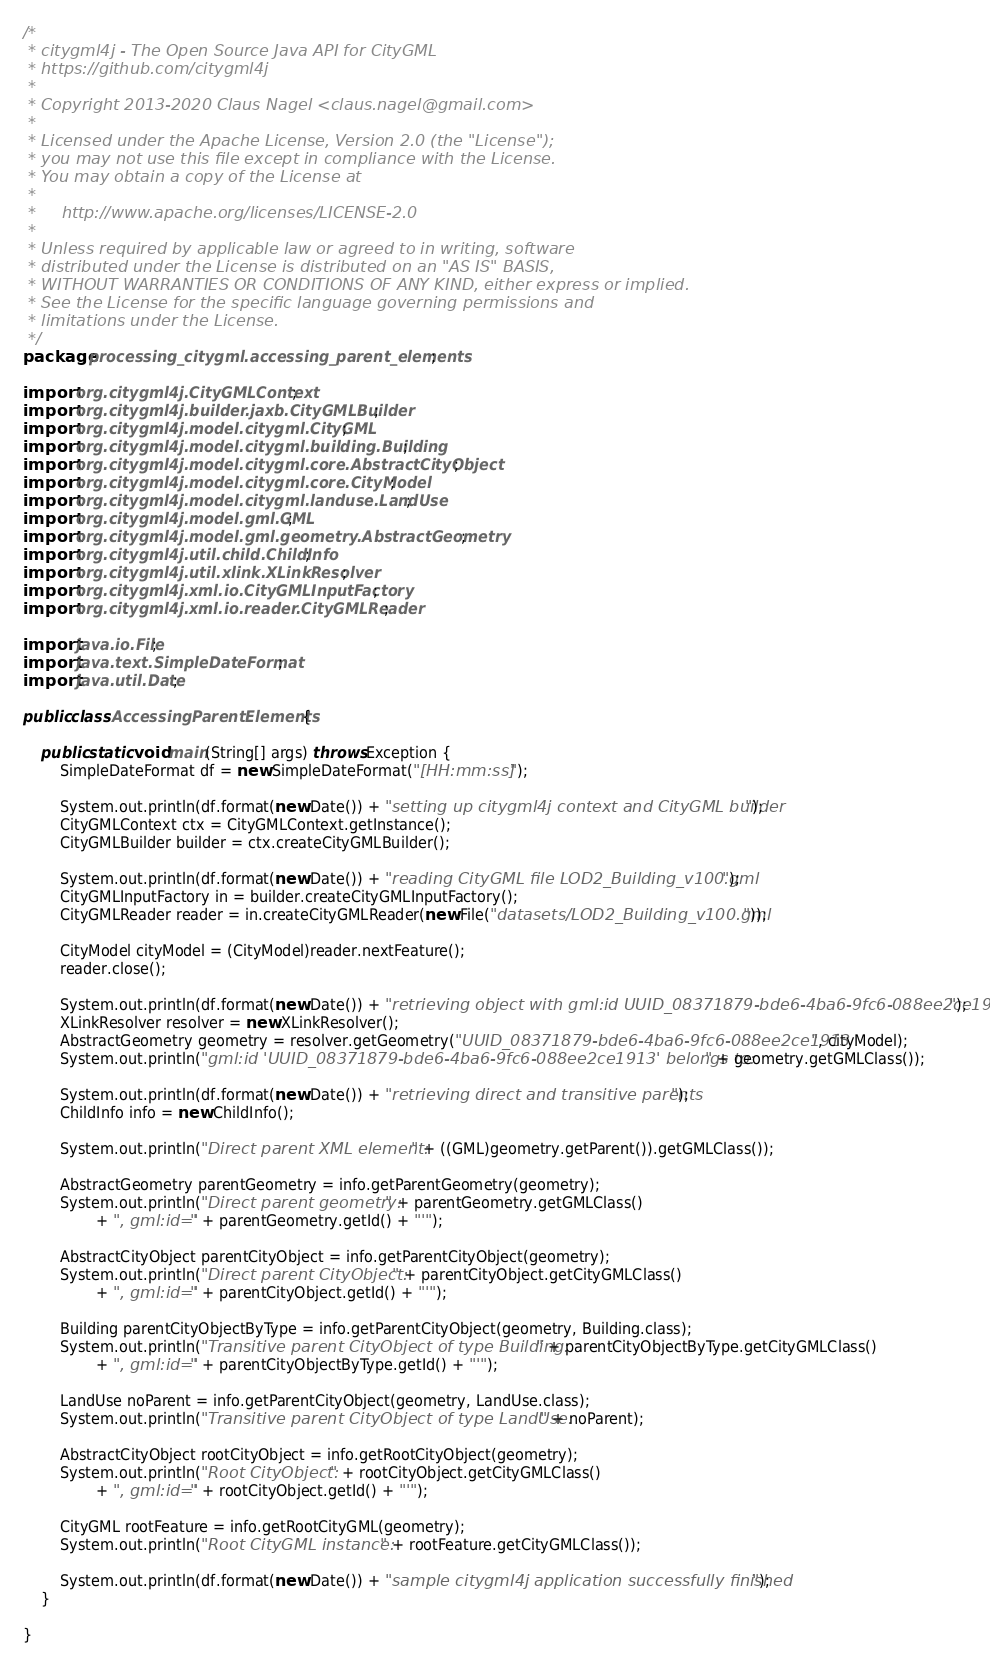Convert code to text. <code><loc_0><loc_0><loc_500><loc_500><_Java_>/*
 * citygml4j - The Open Source Java API for CityGML
 * https://github.com/citygml4j
 *
 * Copyright 2013-2020 Claus Nagel <claus.nagel@gmail.com>
 *
 * Licensed under the Apache License, Version 2.0 (the "License");
 * you may not use this file except in compliance with the License.
 * You may obtain a copy of the License at
 *
 *     http://www.apache.org/licenses/LICENSE-2.0
 *
 * Unless required by applicable law or agreed to in writing, software
 * distributed under the License is distributed on an "AS IS" BASIS,
 * WITHOUT WARRANTIES OR CONDITIONS OF ANY KIND, either express or implied.
 * See the License for the specific language governing permissions and
 * limitations under the License.
 */
package processing_citygml.accessing_parent_elements;

import org.citygml4j.CityGMLContext;
import org.citygml4j.builder.jaxb.CityGMLBuilder;
import org.citygml4j.model.citygml.CityGML;
import org.citygml4j.model.citygml.building.Building;
import org.citygml4j.model.citygml.core.AbstractCityObject;
import org.citygml4j.model.citygml.core.CityModel;
import org.citygml4j.model.citygml.landuse.LandUse;
import org.citygml4j.model.gml.GML;
import org.citygml4j.model.gml.geometry.AbstractGeometry;
import org.citygml4j.util.child.ChildInfo;
import org.citygml4j.util.xlink.XLinkResolver;
import org.citygml4j.xml.io.CityGMLInputFactory;
import org.citygml4j.xml.io.reader.CityGMLReader;

import java.io.File;
import java.text.SimpleDateFormat;
import java.util.Date;

public class AccessingParentElements {

	public static void main(String[] args) throws Exception {
		SimpleDateFormat df = new SimpleDateFormat("[HH:mm:ss] "); 

		System.out.println(df.format(new Date()) + "setting up citygml4j context and CityGML builder");
		CityGMLContext ctx = CityGMLContext.getInstance();
		CityGMLBuilder builder = ctx.createCityGMLBuilder();

		System.out.println(df.format(new Date()) + "reading CityGML file LOD2_Building_v100.gml");
		CityGMLInputFactory in = builder.createCityGMLInputFactory();
		CityGMLReader reader = in.createCityGMLReader(new File("datasets/LOD2_Building_v100.gml"));

		CityModel cityModel = (CityModel)reader.nextFeature();
		reader.close();
		
		System.out.println(df.format(new Date()) + "retrieving object with gml:id UUID_08371879-bde6-4ba6-9fc6-088ee2ce1913");
		XLinkResolver resolver = new XLinkResolver();
		AbstractGeometry geometry = resolver.getGeometry("UUID_08371879-bde6-4ba6-9fc6-088ee2ce1913", cityModel);
		System.out.println("gml:id 'UUID_08371879-bde6-4ba6-9fc6-088ee2ce1913' belongs to: " + geometry.getGMLClass());

		System.out.println(df.format(new Date()) + "retrieving direct and transitive parents");			
		ChildInfo info = new ChildInfo();
		
		System.out.println("Direct parent XML element: " + ((GML)geometry.getParent()).getGMLClass());
		
		AbstractGeometry parentGeometry = info.getParentGeometry(geometry);
		System.out.println("Direct parent geometry: " + parentGeometry.getGMLClass()
				+ ", gml:id='" + parentGeometry.getId() + "'");
		
		AbstractCityObject parentCityObject = info.getParentCityObject(geometry);
		System.out.println("Direct parent CityObject: " + parentCityObject.getCityGMLClass()
				+ ", gml:id='" + parentCityObject.getId() + "'");
		
		Building parentCityObjectByType = info.getParentCityObject(geometry, Building.class);
		System.out.println("Transitive parent CityObject of type Building: " + parentCityObjectByType.getCityGMLClass()
				+ ", gml:id='" + parentCityObjectByType.getId() + "'");

		LandUse noParent = info.getParentCityObject(geometry, LandUse.class);
		System.out.println("Transitive parent CityObject of type LandUse: " + noParent);

		AbstractCityObject rootCityObject = info.getRootCityObject(geometry);
		System.out.println("Root CityObject: " + rootCityObject.getCityGMLClass()
				+ ", gml:id='" + rootCityObject.getId() + "'");
		
		CityGML rootFeature = info.getRootCityGML(geometry);
		System.out.println("Root CityGML instance: " + rootFeature.getCityGMLClass());
		
		System.out.println(df.format(new Date()) + "sample citygml4j application successfully finished");
	}

}
</code> 